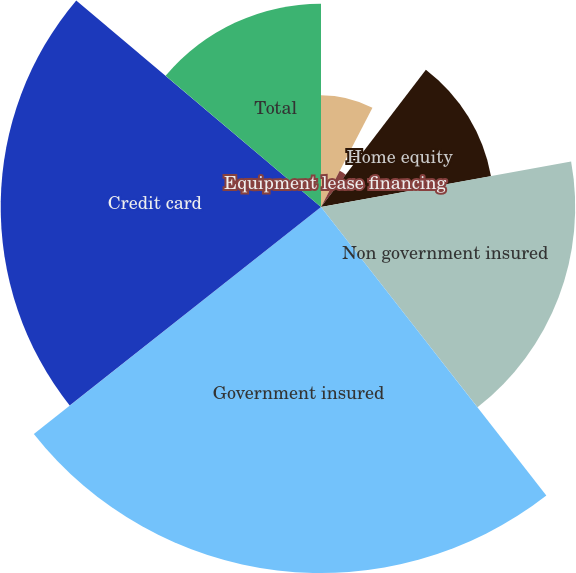<chart> <loc_0><loc_0><loc_500><loc_500><pie_chart><fcel>Commercial real estate<fcel>Equipment lease financing<fcel>Home equity<fcel>Non government insured<fcel>Government insured<fcel>Credit card<fcel>Total<nl><fcel>7.61%<fcel>2.77%<fcel>11.76%<fcel>17.3%<fcel>24.91%<fcel>21.8%<fcel>13.84%<nl></chart> 